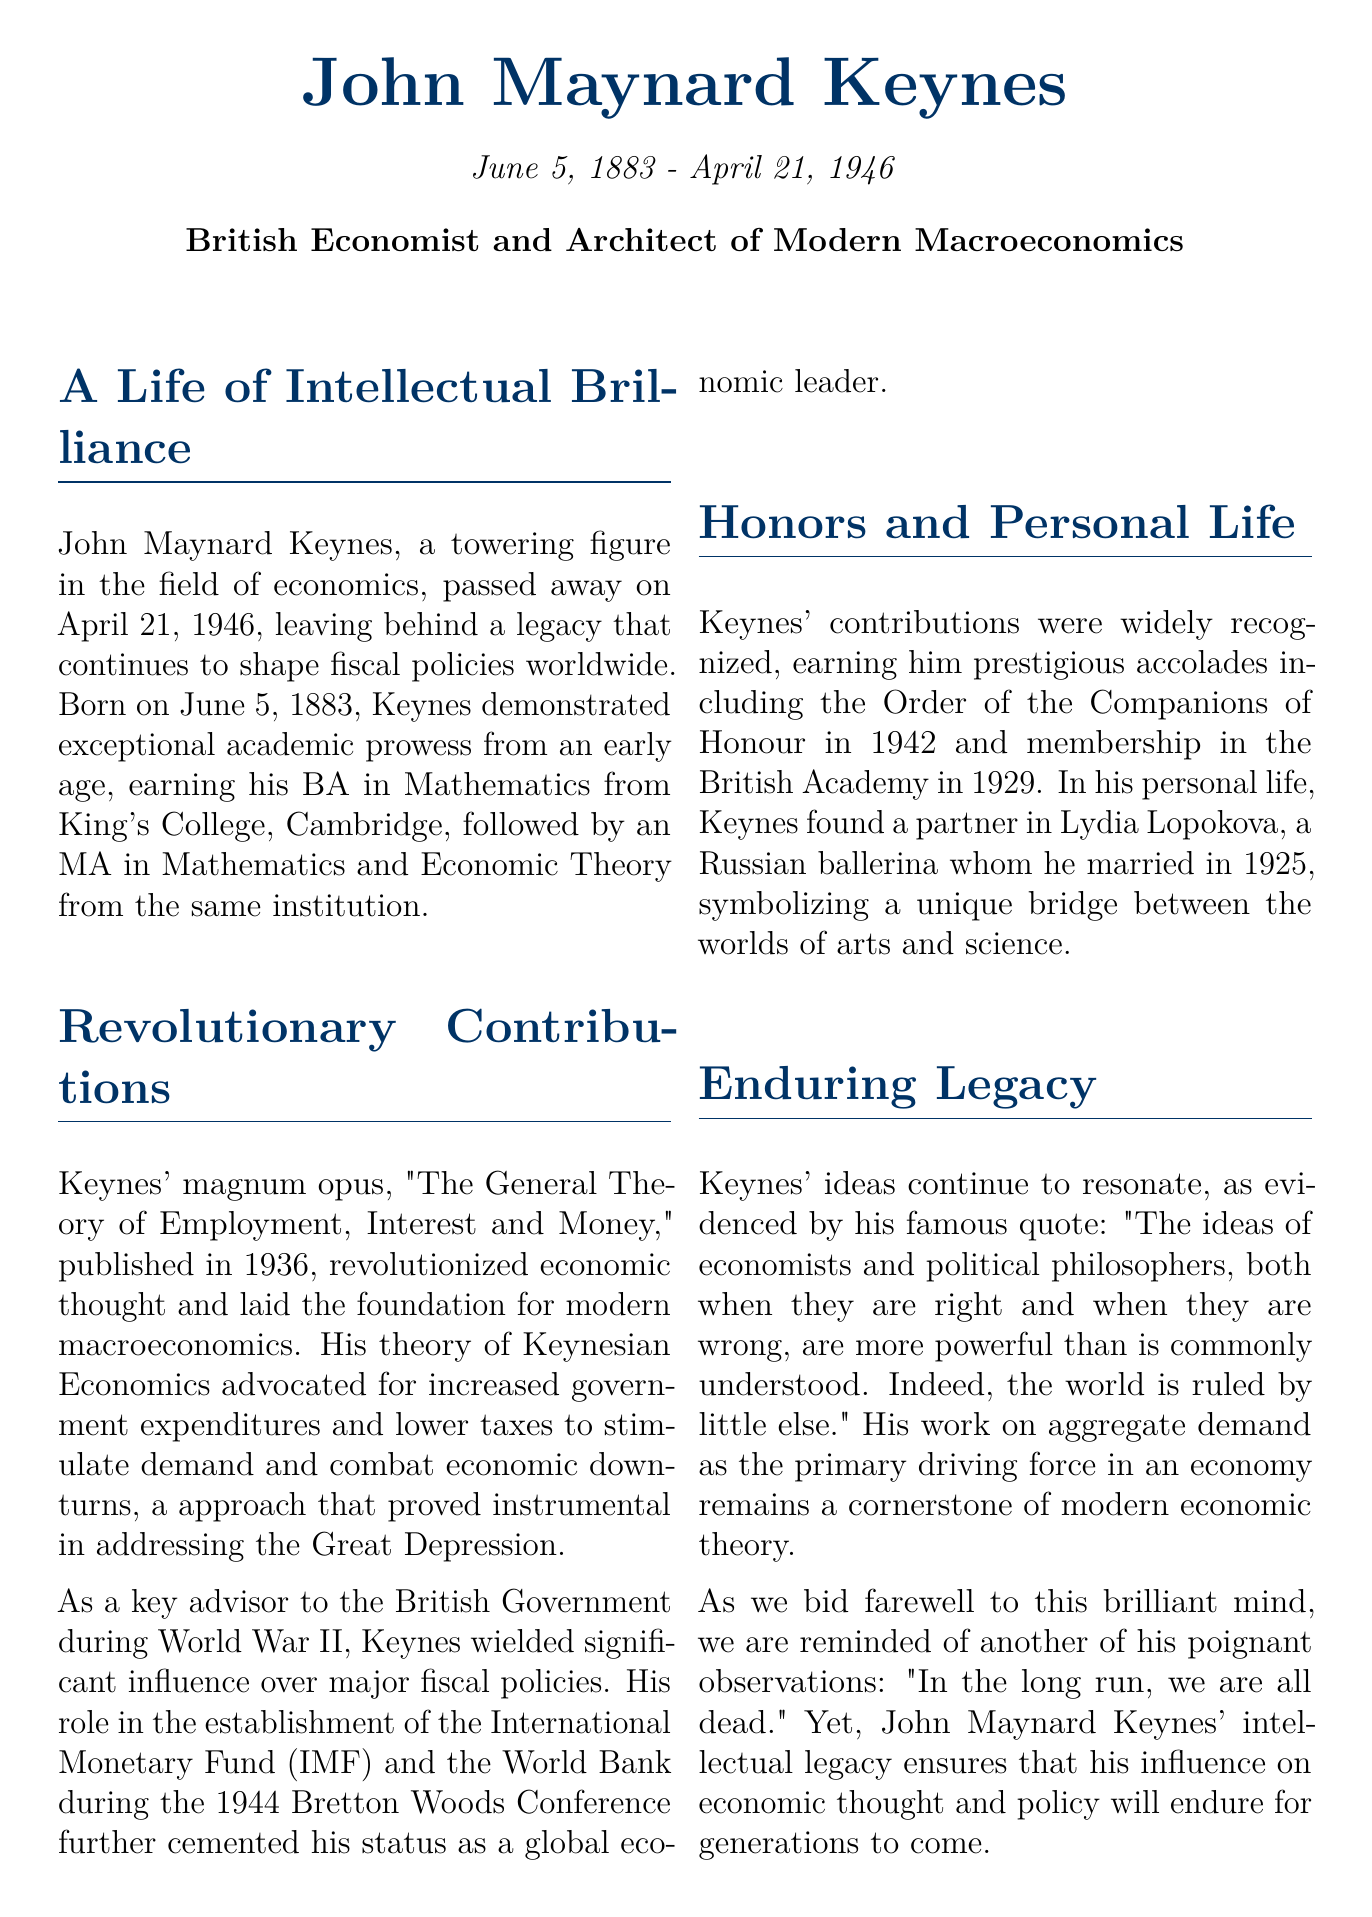What is the full name of the economist? The document explicitly states the full name of the economist as John Maynard Keynes.
Answer: John Maynard Keynes When was John Maynard Keynes born? The document mentions his birth date as June 5, 1883.
Answer: June 5, 1883 What is the title of Keynes' magnum opus? The document specifies the title of Keynes' significant work as "The General Theory of Employment, Interest and Money."
Answer: The General Theory of Employment, Interest and Money What year was "The General Theory of Employment, Interest and Money" published? The document indicates that this key work was published in 1936.
Answer: 1936 What prestigious accolade did Keynes receive in 1942? The document notes that Keynes earned the Order of the Companions of Honour in 1942.
Answer: Order of the Companions of Honour Which major international organizations did Keynes help establish? The document cites his role in the establishment of the International Monetary Fund and the World Bank during the Bretton Woods Conference.
Answer: International Monetary Fund and World Bank Who was Keynes' spouse? According to the document, his partner was Lydia Lopokova.
Answer: Lydia Lopokova What was a key aspect of Keynesian Economics? The document describes increased government expenditures and lower taxes to stimulate demand as central to Keynesian Economics.
Answer: Increased government expenditures and lower taxes What quote from Keynes reflects his view on the influence of economists? The document quotes Keynes saying, "The ideas of economists and political philosophers... are more powerful than is commonly understood."
Answer: The ideas of economists and political philosophers... are more powerful than is commonly understood What did Keynes famously state about the long run? The document states his quote: "In the long run, we are all dead."
Answer: In the long run, we are all dead 